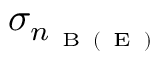<formula> <loc_0><loc_0><loc_500><loc_500>\sigma _ { n _ { B ( E ) } }</formula> 